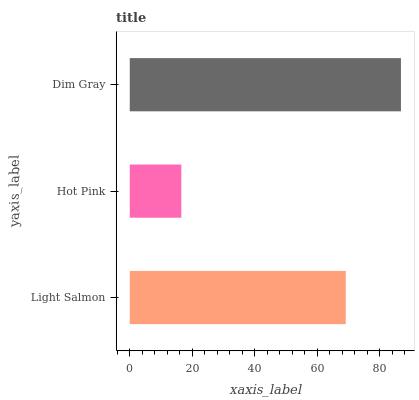Is Hot Pink the minimum?
Answer yes or no. Yes. Is Dim Gray the maximum?
Answer yes or no. Yes. Is Dim Gray the minimum?
Answer yes or no. No. Is Hot Pink the maximum?
Answer yes or no. No. Is Dim Gray greater than Hot Pink?
Answer yes or no. Yes. Is Hot Pink less than Dim Gray?
Answer yes or no. Yes. Is Hot Pink greater than Dim Gray?
Answer yes or no. No. Is Dim Gray less than Hot Pink?
Answer yes or no. No. Is Light Salmon the high median?
Answer yes or no. Yes. Is Light Salmon the low median?
Answer yes or no. Yes. Is Dim Gray the high median?
Answer yes or no. No. Is Hot Pink the low median?
Answer yes or no. No. 